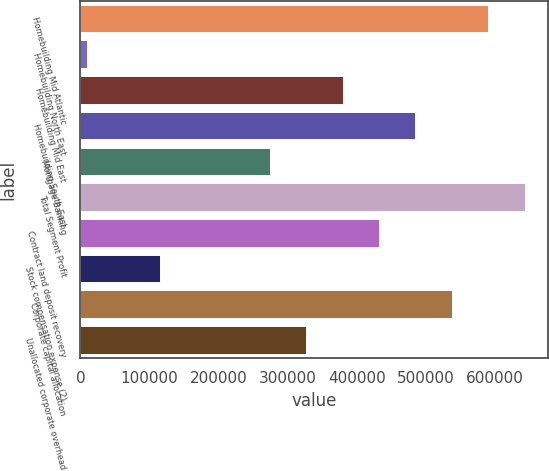Convert chart to OTSL. <chart><loc_0><loc_0><loc_500><loc_500><bar_chart><fcel>Homebuilding Mid Atlantic<fcel>Homebuilding North East<fcel>Homebuilding Mid East<fcel>Homebuilding South East<fcel>Mortgage Banking<fcel>Total Segment Profit<fcel>Contract land deposit recovery<fcel>Stock compensation expense (2)<fcel>Corporate capital allocation<fcel>Unallocated corporate overhead<nl><fcel>592338<fcel>11176<fcel>381006<fcel>486672<fcel>275340<fcel>645171<fcel>433839<fcel>116842<fcel>539505<fcel>328173<nl></chart> 